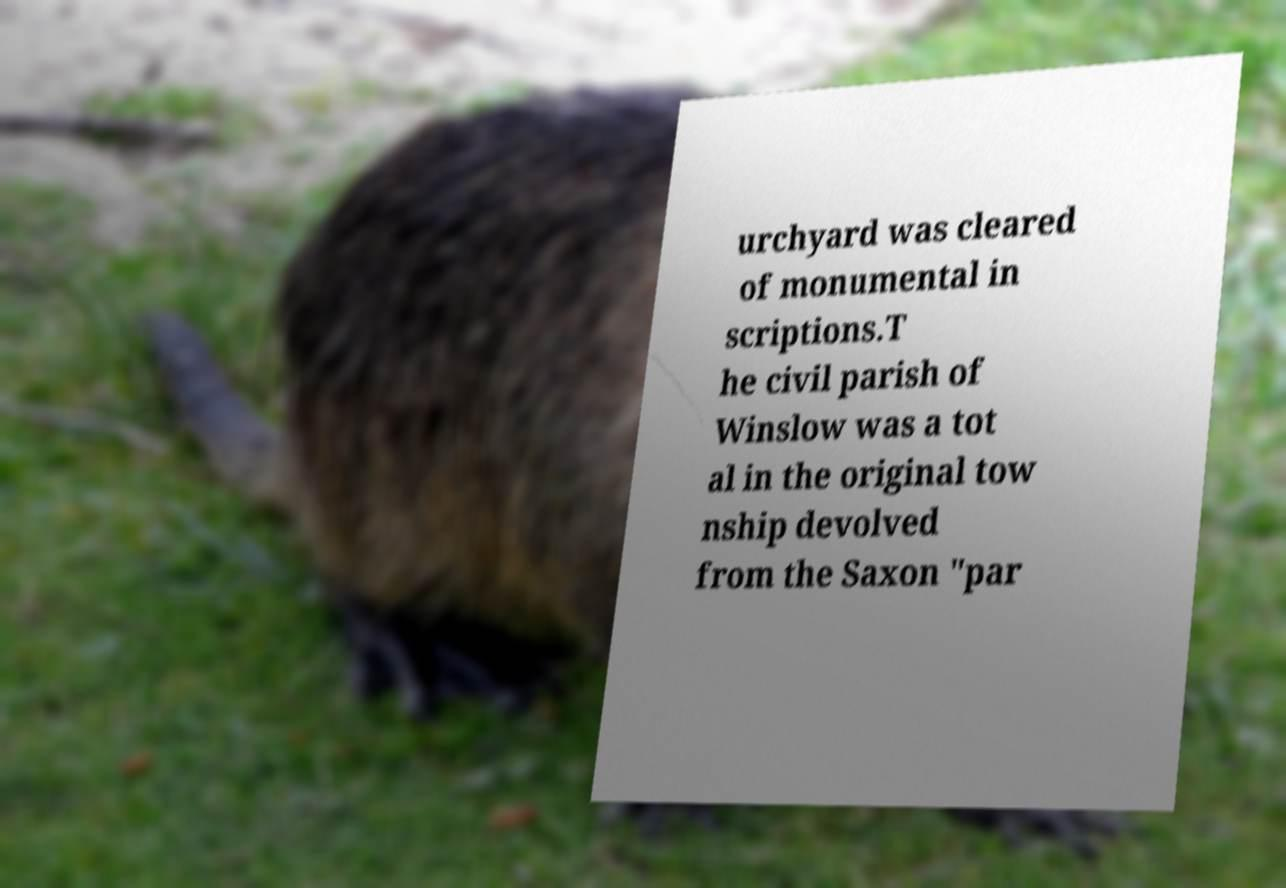For documentation purposes, I need the text within this image transcribed. Could you provide that? urchyard was cleared of monumental in scriptions.T he civil parish of Winslow was a tot al in the original tow nship devolved from the Saxon "par 